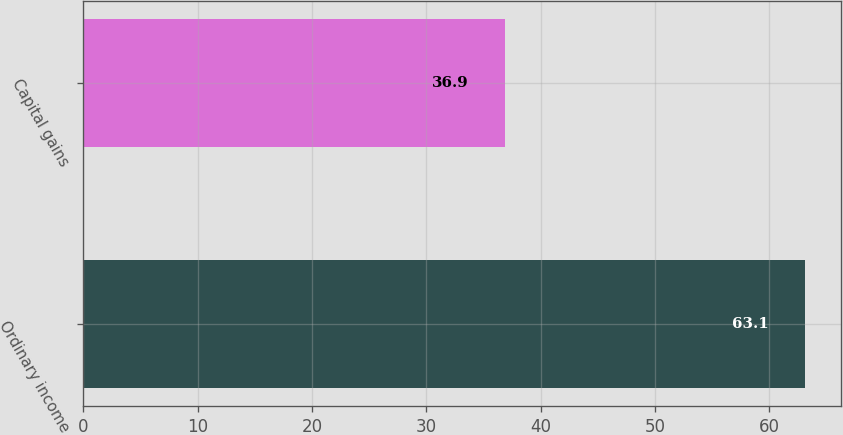<chart> <loc_0><loc_0><loc_500><loc_500><bar_chart><fcel>Ordinary income<fcel>Capital gains<nl><fcel>63.1<fcel>36.9<nl></chart> 